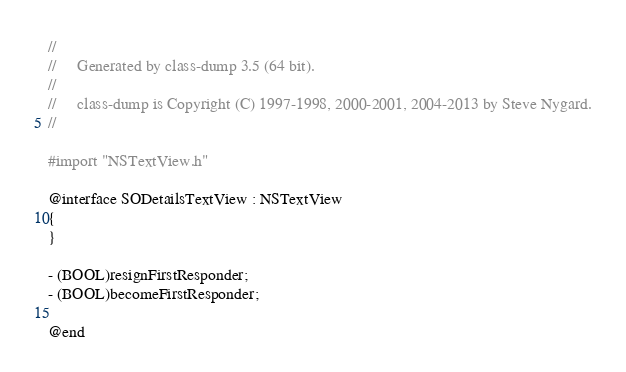Convert code to text. <code><loc_0><loc_0><loc_500><loc_500><_C_>//
//     Generated by class-dump 3.5 (64 bit).
//
//     class-dump is Copyright (C) 1997-1998, 2000-2001, 2004-2013 by Steve Nygard.
//

#import "NSTextView.h"

@interface SODetailsTextView : NSTextView
{
}

- (BOOL)resignFirstResponder;
- (BOOL)becomeFirstResponder;

@end

</code> 